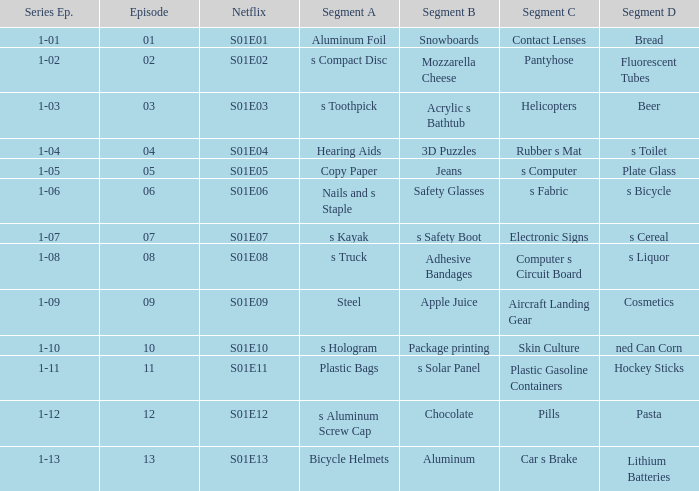What is the segment A name, having a Netflix of s01e12? S aluminum screw cap. 